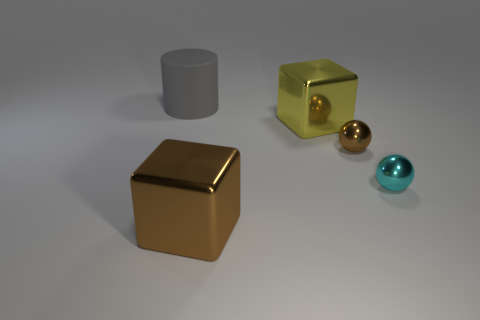What objects can you identify in the image? The image features five objects: one large grey cylinder, one yellow translucent cube, one large gold cube, one small gold sphere, and one small turquoise sphere.  Can you tell if the lighting is natural or artificial? The shadows and reflections on the objects suggest that the lighting in the image is artificial, coming from a source off-camera, likely created to mimic a soft and diffused natural light. 